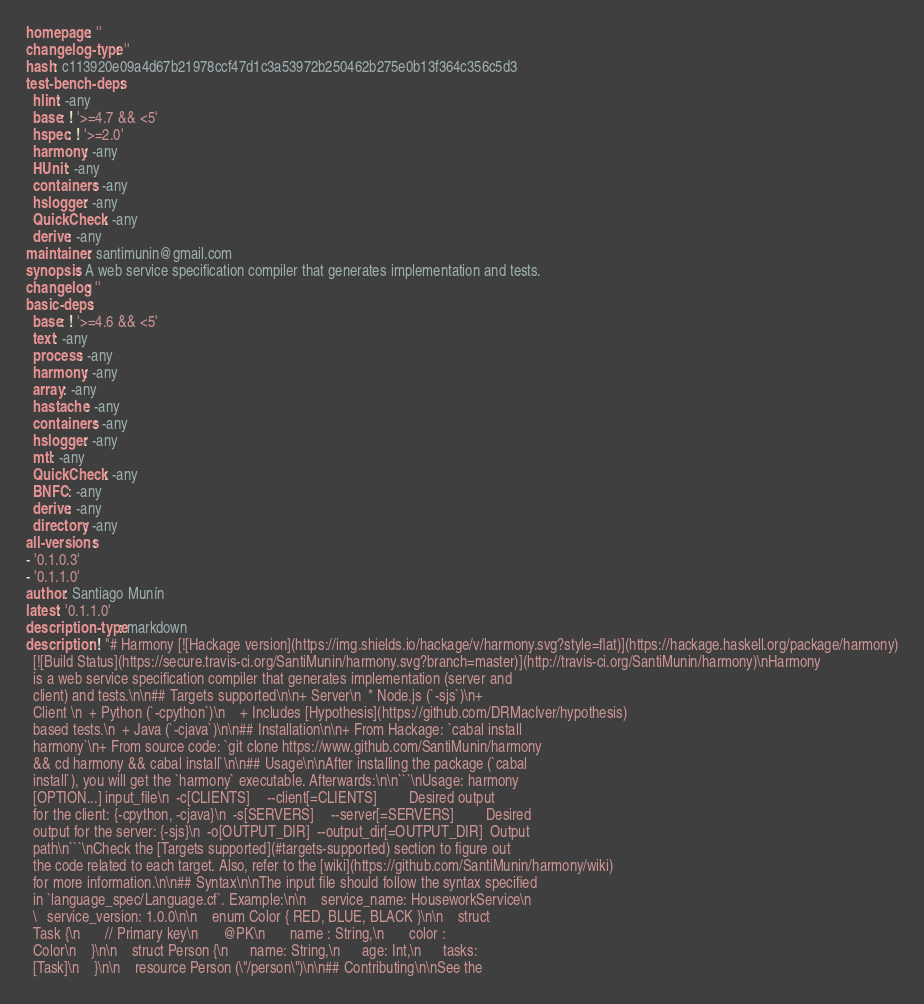Convert code to text. <code><loc_0><loc_0><loc_500><loc_500><_YAML_>homepage: ''
changelog-type: ''
hash: c113920e09a4d67b21978ccf47d1c3a53972b250462b275e0b13f364c356c5d3
test-bench-deps:
  hlint: -any
  base: ! '>=4.7 && <5'
  hspec: ! '>=2.0'
  harmony: -any
  HUnit: -any
  containers: -any
  hslogger: -any
  QuickCheck: -any
  derive: -any
maintainer: santimunin@gmail.com
synopsis: A web service specification compiler that generates implementation and tests.
changelog: ''
basic-deps:
  base: ! '>=4.6 && <5'
  text: -any
  process: -any
  harmony: -any
  array: -any
  hastache: -any
  containers: -any
  hslogger: -any
  mtl: -any
  QuickCheck: -any
  BNFC: -any
  derive: -any
  directory: -any
all-versions:
- '0.1.0.3'
- '0.1.1.0'
author: Santiago Munín
latest: '0.1.1.0'
description-type: markdown
description: ! "# Harmony [![Hackage version](https://img.shields.io/hackage/v/harmony.svg?style=flat)](https://hackage.haskell.org/package/harmony)
  [![Build Status](https://secure.travis-ci.org/SantiMunin/harmony.svg?branch=master)](http://travis-ci.org/SantiMunin/harmony)\nHarmony
  is a web service specification compiler that generates implementation (server and
  client) and tests.\n\n## Targets supported\n\n+ Server\n  * Node.js (`-sjs`)\n+
  Client \n  + Python (`-cpython`)\n    + Includes [Hypothesis](https://github.com/DRMacIver/hypothesis)
  based tests.\n  + Java (`-cjava`)\n\n## Installation\n\n+ From Hackage: `cabal install
  harmony`\n+ From source code: `git clone https://www.github.com/SantiMunin/harmony
  && cd harmony && cabal install`\n\n## Usage\n\nAfter installing the package (`cabal
  install`), you will get the `harmony` executable. Afterwards:\n\n```\nUsage: harmony
  [OPTION...] input_file\n  -c[CLIENTS]     --client[=CLIENTS]         Desired output
  for the client: {-cpython, -cjava}\n  -s[SERVERS]     --server[=SERVERS]         Desired
  output for the server: {-sjs}\n  -o[OUTPUT_DIR]  --output_dir[=OUTPUT_DIR]  Output
  path\n```\nCheck the [Targets supported](#targets-supported) section to figure out
  the code related to each target. Also, refer to the [wiki](https://github.com/SantiMunin/harmony/wiki)
  for more information.\n\n## Syntax\n\nThe input file should follow the syntax specified
  in `language_spec/Language.cf`. Example:\n\n    service_name: HouseworkService\n
  \   service_version: 1.0.0\n\n    enum Color { RED, BLUE, BLACK }\n\n    struct
  Task {\n       // Primary key\n       @PK\n       name : String,\n       color :
  Color\n    }\n\n    struct Person {\n      name: String,\n      age: Int,\n      tasks:
  [Task]\n    }\n\n    resource Person (\"/person\")\n\n## Contributing\n\nSee the</code> 